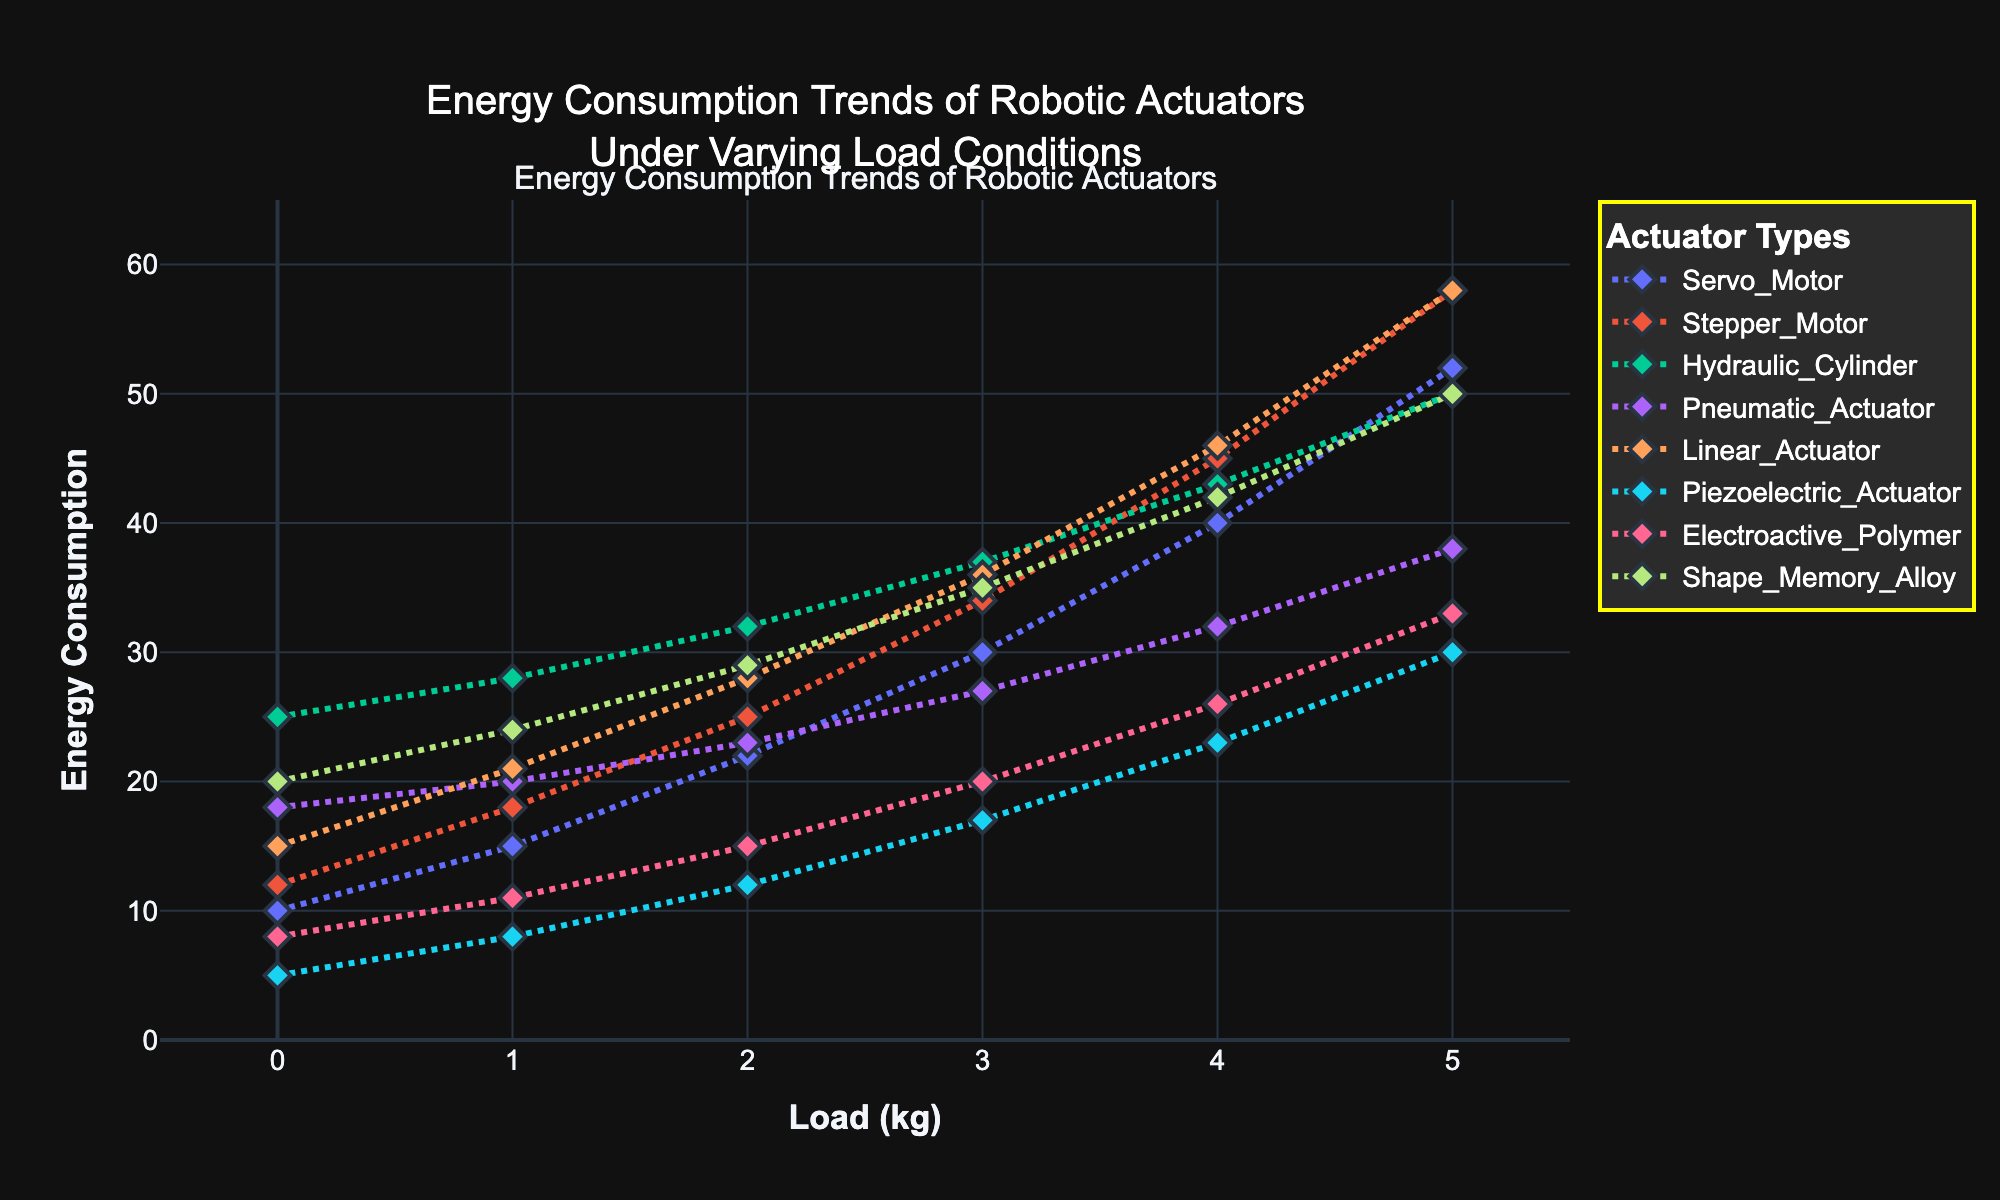what actuator shows the least energy consumption under a 5kg load? By observing the plot, the actuator with the least y-axis value at the 5kg load mark is the Piezoelectric Actuator because its line plot is the lowest on the chart
Answer: Piezoelectric Actuator Which actuator has the largest increase in energy consumption from 0kg to 5kg? Calculate the energy consumption increase for each actuator from 0kg to 5kg: Servo Motor (52-10=42), Stepper Motor (58-12=46), Hydraulic Cylinder (50-25=25), Pneumatic Actuator (38-18=20), Linear Actuator (58-15=43), Piezoelectric Actuator (30-5=25), Electroactive Polymer (33-8=25), Shape Memory Alloy (50-20=30). The Stepper Motor has the largest increase of 46 units
Answer: Stepper Motor Between the Stepper Motor and the Linear Actuator, which consumes more energy at a 2kg load? Observe the y-axis values at the 2kg load mark for both actuators. Stepper Motor has a value of 25, while Linear Actuator has 28, so Linear Actuator consumes more energy
Answer: Linear Actuator What is the average energy consumption of the Servo Motor across all load conditions? Add all the energy consumption values for the Servo Motor and divide by the number of load conditions: (10+15+22+30+40+52)/6 = 169/6 = 28.17
Answer: 28.17 Which actuator's energy consumption trend shows the steepest incline? The slope of the lines indicates the rate of increase. The actuator line that rises most steeply is the Stepper Motor, which has the most significant upward slope from 0kg to 5kg
Answer: Stepper Motor Calculate the total energy consumption for the Hydraulic Cylinder and Shape Memory Alloy at a 3kg load. Add the energy consumption values at a 3kg load for both actuators: Hydraulic Cylinder (37) + Shape Memory Alloy (35) = 72
Answer: 72 Which actuator shows a consistent increase in energy consumption without any plateaus or dips? By observing the trends, all actuators show consistent increases without plateaus or dips, but Piezoelectric Actuator has the smoothest upward trajectory without fluctuations
Answer: Piezoelectric Actuator Is the Stepper Motor's energy consumption at a 1kg load higher than the Servo Motor's energy consumption at a 4kg load? Compare the y-axis values of Stepper Motor at 1kg (18) and Servo Motor at 4kg (40). Stepper Motor at 1kg (18) is less than Servo Motor at 4kg (40)
Answer: No 